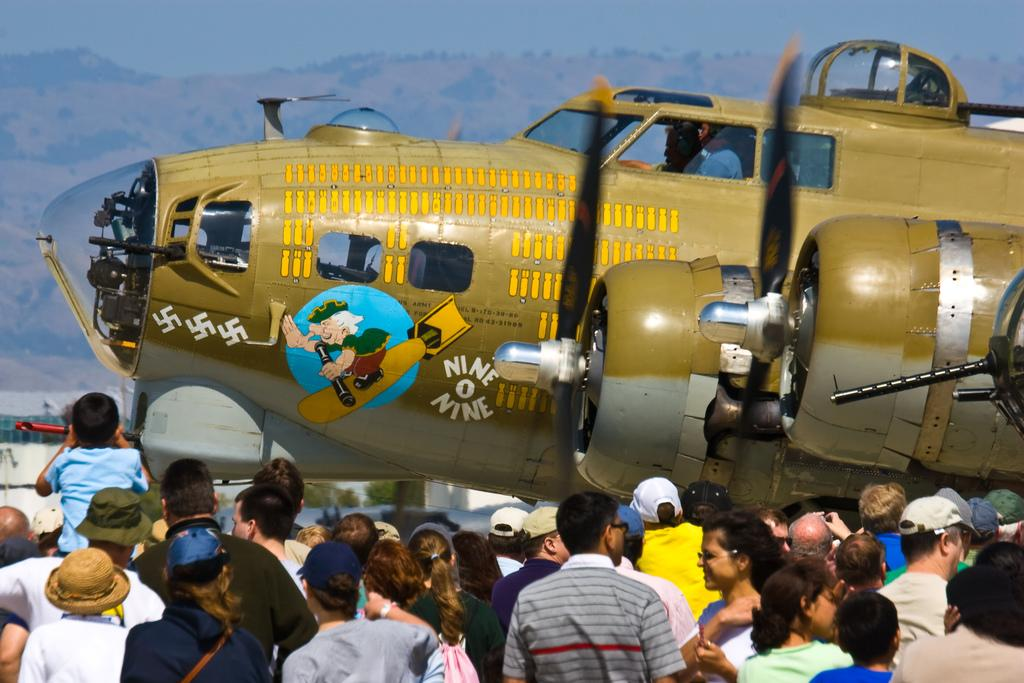What is the main subject of the image? The main subject of the image is an aeroplane. What can be seen at the bottom of the image? There are many people at the bottom of the image. What type of natural landscape is visible in the background of the image? There are mountains in the background of the image. What else can be seen in the background of the image? The sky is visible in the background of the image. What type of rice is being cooked in the image? There is no rice present in the image. Can you see a toad hopping near the aeroplane in the image? There is no toad present in the image. 